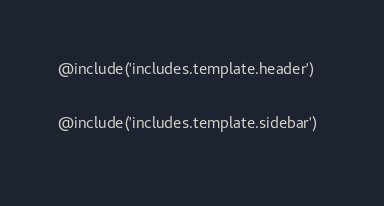<code> <loc_0><loc_0><loc_500><loc_500><_PHP_>
@include('includes.template.header')


@include('includes.template.sidebar')  
            
</code> 